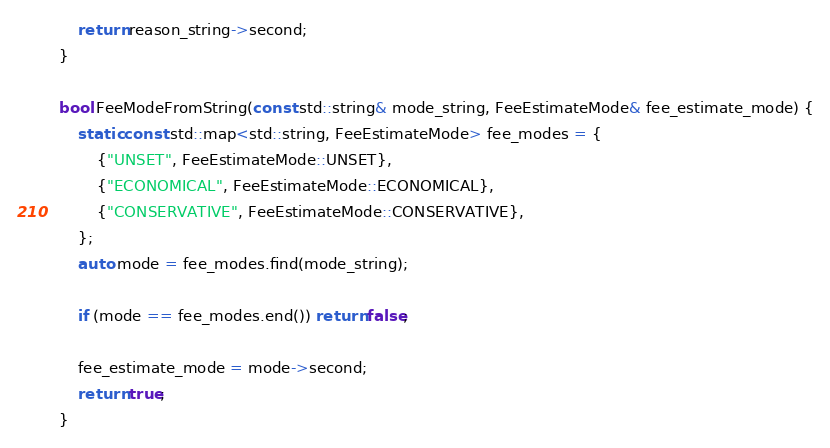Convert code to text. <code><loc_0><loc_0><loc_500><loc_500><_C++_>
    return reason_string->second;
}

bool FeeModeFromString(const std::string& mode_string, FeeEstimateMode& fee_estimate_mode) {
    static const std::map<std::string, FeeEstimateMode> fee_modes = {
        {"UNSET", FeeEstimateMode::UNSET},
        {"ECONOMICAL", FeeEstimateMode::ECONOMICAL},
        {"CONSERVATIVE", FeeEstimateMode::CONSERVATIVE},
    };
    auto mode = fee_modes.find(mode_string);

    if (mode == fee_modes.end()) return false;

    fee_estimate_mode = mode->second;
    return true;
}
</code> 